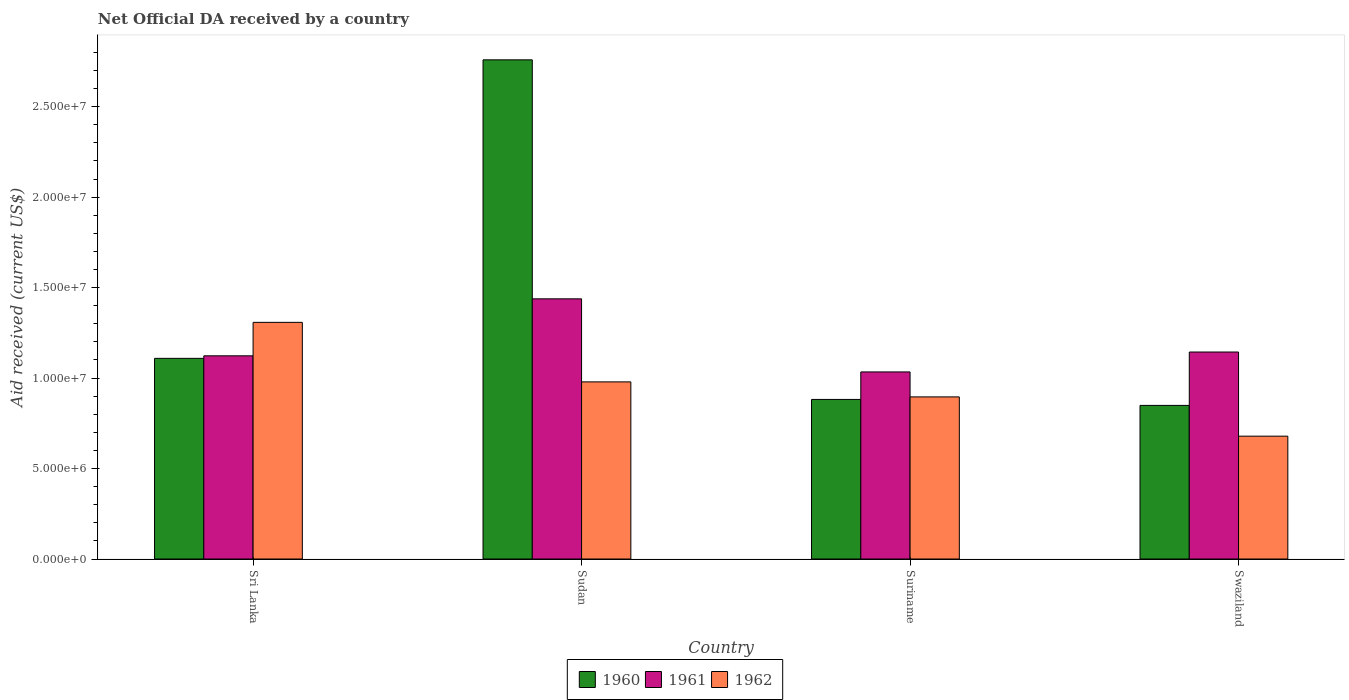Are the number of bars per tick equal to the number of legend labels?
Provide a succinct answer. Yes. What is the label of the 3rd group of bars from the left?
Offer a terse response. Suriname. What is the net official development assistance aid received in 1961 in Sudan?
Provide a short and direct response. 1.44e+07. Across all countries, what is the maximum net official development assistance aid received in 1961?
Provide a short and direct response. 1.44e+07. Across all countries, what is the minimum net official development assistance aid received in 1961?
Offer a terse response. 1.03e+07. In which country was the net official development assistance aid received in 1962 maximum?
Make the answer very short. Sri Lanka. In which country was the net official development assistance aid received in 1960 minimum?
Make the answer very short. Swaziland. What is the total net official development assistance aid received in 1960 in the graph?
Provide a short and direct response. 5.60e+07. What is the difference between the net official development assistance aid received in 1961 in Sudan and that in Swaziland?
Ensure brevity in your answer.  2.94e+06. What is the difference between the net official development assistance aid received in 1961 in Sri Lanka and the net official development assistance aid received in 1962 in Sudan?
Keep it short and to the point. 1.44e+06. What is the average net official development assistance aid received in 1962 per country?
Make the answer very short. 9.66e+06. What is the difference between the net official development assistance aid received of/in 1960 and net official development assistance aid received of/in 1962 in Swaziland?
Your response must be concise. 1.70e+06. What is the ratio of the net official development assistance aid received in 1961 in Sri Lanka to that in Suriname?
Keep it short and to the point. 1.09. What is the difference between the highest and the second highest net official development assistance aid received in 1961?
Your answer should be very brief. 3.15e+06. What is the difference between the highest and the lowest net official development assistance aid received in 1960?
Your response must be concise. 1.91e+07. In how many countries, is the net official development assistance aid received in 1960 greater than the average net official development assistance aid received in 1960 taken over all countries?
Keep it short and to the point. 1. What does the 1st bar from the right in Swaziland represents?
Your answer should be very brief. 1962. Is it the case that in every country, the sum of the net official development assistance aid received in 1962 and net official development assistance aid received in 1960 is greater than the net official development assistance aid received in 1961?
Offer a terse response. Yes. Are all the bars in the graph horizontal?
Give a very brief answer. No. What is the difference between two consecutive major ticks on the Y-axis?
Ensure brevity in your answer.  5.00e+06. Are the values on the major ticks of Y-axis written in scientific E-notation?
Your answer should be compact. Yes. Does the graph contain any zero values?
Offer a terse response. No. How many legend labels are there?
Give a very brief answer. 3. How are the legend labels stacked?
Your answer should be compact. Horizontal. What is the title of the graph?
Your answer should be very brief. Net Official DA received by a country. What is the label or title of the Y-axis?
Offer a terse response. Aid received (current US$). What is the Aid received (current US$) of 1960 in Sri Lanka?
Provide a succinct answer. 1.11e+07. What is the Aid received (current US$) in 1961 in Sri Lanka?
Provide a short and direct response. 1.12e+07. What is the Aid received (current US$) in 1962 in Sri Lanka?
Offer a terse response. 1.31e+07. What is the Aid received (current US$) of 1960 in Sudan?
Give a very brief answer. 2.76e+07. What is the Aid received (current US$) in 1961 in Sudan?
Your answer should be very brief. 1.44e+07. What is the Aid received (current US$) in 1962 in Sudan?
Your answer should be very brief. 9.79e+06. What is the Aid received (current US$) in 1960 in Suriname?
Keep it short and to the point. 8.82e+06. What is the Aid received (current US$) of 1961 in Suriname?
Your response must be concise. 1.03e+07. What is the Aid received (current US$) in 1962 in Suriname?
Your answer should be compact. 8.96e+06. What is the Aid received (current US$) in 1960 in Swaziland?
Ensure brevity in your answer.  8.49e+06. What is the Aid received (current US$) of 1961 in Swaziland?
Offer a very short reply. 1.14e+07. What is the Aid received (current US$) in 1962 in Swaziland?
Give a very brief answer. 6.79e+06. Across all countries, what is the maximum Aid received (current US$) in 1960?
Your response must be concise. 2.76e+07. Across all countries, what is the maximum Aid received (current US$) of 1961?
Your answer should be very brief. 1.44e+07. Across all countries, what is the maximum Aid received (current US$) in 1962?
Provide a short and direct response. 1.31e+07. Across all countries, what is the minimum Aid received (current US$) in 1960?
Provide a short and direct response. 8.49e+06. Across all countries, what is the minimum Aid received (current US$) in 1961?
Provide a succinct answer. 1.03e+07. Across all countries, what is the minimum Aid received (current US$) in 1962?
Provide a succinct answer. 6.79e+06. What is the total Aid received (current US$) in 1960 in the graph?
Provide a succinct answer. 5.60e+07. What is the total Aid received (current US$) of 1961 in the graph?
Offer a very short reply. 4.74e+07. What is the total Aid received (current US$) in 1962 in the graph?
Your answer should be very brief. 3.86e+07. What is the difference between the Aid received (current US$) in 1960 in Sri Lanka and that in Sudan?
Offer a very short reply. -1.65e+07. What is the difference between the Aid received (current US$) of 1961 in Sri Lanka and that in Sudan?
Keep it short and to the point. -3.15e+06. What is the difference between the Aid received (current US$) in 1962 in Sri Lanka and that in Sudan?
Give a very brief answer. 3.29e+06. What is the difference between the Aid received (current US$) in 1960 in Sri Lanka and that in Suriname?
Give a very brief answer. 2.27e+06. What is the difference between the Aid received (current US$) of 1961 in Sri Lanka and that in Suriname?
Offer a very short reply. 8.90e+05. What is the difference between the Aid received (current US$) in 1962 in Sri Lanka and that in Suriname?
Offer a terse response. 4.12e+06. What is the difference between the Aid received (current US$) of 1960 in Sri Lanka and that in Swaziland?
Ensure brevity in your answer.  2.60e+06. What is the difference between the Aid received (current US$) in 1962 in Sri Lanka and that in Swaziland?
Give a very brief answer. 6.29e+06. What is the difference between the Aid received (current US$) of 1960 in Sudan and that in Suriname?
Offer a terse response. 1.88e+07. What is the difference between the Aid received (current US$) in 1961 in Sudan and that in Suriname?
Provide a succinct answer. 4.04e+06. What is the difference between the Aid received (current US$) in 1962 in Sudan and that in Suriname?
Give a very brief answer. 8.30e+05. What is the difference between the Aid received (current US$) of 1960 in Sudan and that in Swaziland?
Give a very brief answer. 1.91e+07. What is the difference between the Aid received (current US$) of 1961 in Sudan and that in Swaziland?
Your answer should be very brief. 2.94e+06. What is the difference between the Aid received (current US$) of 1962 in Sudan and that in Swaziland?
Give a very brief answer. 3.00e+06. What is the difference between the Aid received (current US$) of 1960 in Suriname and that in Swaziland?
Keep it short and to the point. 3.30e+05. What is the difference between the Aid received (current US$) of 1961 in Suriname and that in Swaziland?
Make the answer very short. -1.10e+06. What is the difference between the Aid received (current US$) of 1962 in Suriname and that in Swaziland?
Your answer should be very brief. 2.17e+06. What is the difference between the Aid received (current US$) of 1960 in Sri Lanka and the Aid received (current US$) of 1961 in Sudan?
Provide a succinct answer. -3.29e+06. What is the difference between the Aid received (current US$) of 1960 in Sri Lanka and the Aid received (current US$) of 1962 in Sudan?
Ensure brevity in your answer.  1.30e+06. What is the difference between the Aid received (current US$) in 1961 in Sri Lanka and the Aid received (current US$) in 1962 in Sudan?
Your answer should be very brief. 1.44e+06. What is the difference between the Aid received (current US$) in 1960 in Sri Lanka and the Aid received (current US$) in 1961 in Suriname?
Make the answer very short. 7.50e+05. What is the difference between the Aid received (current US$) of 1960 in Sri Lanka and the Aid received (current US$) of 1962 in Suriname?
Your response must be concise. 2.13e+06. What is the difference between the Aid received (current US$) in 1961 in Sri Lanka and the Aid received (current US$) in 1962 in Suriname?
Provide a short and direct response. 2.27e+06. What is the difference between the Aid received (current US$) in 1960 in Sri Lanka and the Aid received (current US$) in 1961 in Swaziland?
Offer a very short reply. -3.50e+05. What is the difference between the Aid received (current US$) of 1960 in Sri Lanka and the Aid received (current US$) of 1962 in Swaziland?
Provide a short and direct response. 4.30e+06. What is the difference between the Aid received (current US$) in 1961 in Sri Lanka and the Aid received (current US$) in 1962 in Swaziland?
Your answer should be compact. 4.44e+06. What is the difference between the Aid received (current US$) of 1960 in Sudan and the Aid received (current US$) of 1961 in Suriname?
Ensure brevity in your answer.  1.72e+07. What is the difference between the Aid received (current US$) in 1960 in Sudan and the Aid received (current US$) in 1962 in Suriname?
Your answer should be compact. 1.86e+07. What is the difference between the Aid received (current US$) in 1961 in Sudan and the Aid received (current US$) in 1962 in Suriname?
Offer a very short reply. 5.42e+06. What is the difference between the Aid received (current US$) in 1960 in Sudan and the Aid received (current US$) in 1961 in Swaziland?
Provide a succinct answer. 1.62e+07. What is the difference between the Aid received (current US$) of 1960 in Sudan and the Aid received (current US$) of 1962 in Swaziland?
Offer a terse response. 2.08e+07. What is the difference between the Aid received (current US$) of 1961 in Sudan and the Aid received (current US$) of 1962 in Swaziland?
Provide a short and direct response. 7.59e+06. What is the difference between the Aid received (current US$) of 1960 in Suriname and the Aid received (current US$) of 1961 in Swaziland?
Offer a terse response. -2.62e+06. What is the difference between the Aid received (current US$) of 1960 in Suriname and the Aid received (current US$) of 1962 in Swaziland?
Make the answer very short. 2.03e+06. What is the difference between the Aid received (current US$) in 1961 in Suriname and the Aid received (current US$) in 1962 in Swaziland?
Provide a succinct answer. 3.55e+06. What is the average Aid received (current US$) in 1960 per country?
Offer a very short reply. 1.40e+07. What is the average Aid received (current US$) in 1961 per country?
Provide a succinct answer. 1.18e+07. What is the average Aid received (current US$) in 1962 per country?
Keep it short and to the point. 9.66e+06. What is the difference between the Aid received (current US$) of 1960 and Aid received (current US$) of 1962 in Sri Lanka?
Your answer should be compact. -1.99e+06. What is the difference between the Aid received (current US$) in 1961 and Aid received (current US$) in 1962 in Sri Lanka?
Ensure brevity in your answer.  -1.85e+06. What is the difference between the Aid received (current US$) of 1960 and Aid received (current US$) of 1961 in Sudan?
Your answer should be very brief. 1.32e+07. What is the difference between the Aid received (current US$) in 1960 and Aid received (current US$) in 1962 in Sudan?
Provide a succinct answer. 1.78e+07. What is the difference between the Aid received (current US$) in 1961 and Aid received (current US$) in 1962 in Sudan?
Give a very brief answer. 4.59e+06. What is the difference between the Aid received (current US$) in 1960 and Aid received (current US$) in 1961 in Suriname?
Your answer should be very brief. -1.52e+06. What is the difference between the Aid received (current US$) in 1961 and Aid received (current US$) in 1962 in Suriname?
Your answer should be compact. 1.38e+06. What is the difference between the Aid received (current US$) of 1960 and Aid received (current US$) of 1961 in Swaziland?
Give a very brief answer. -2.95e+06. What is the difference between the Aid received (current US$) in 1960 and Aid received (current US$) in 1962 in Swaziland?
Give a very brief answer. 1.70e+06. What is the difference between the Aid received (current US$) of 1961 and Aid received (current US$) of 1962 in Swaziland?
Provide a succinct answer. 4.65e+06. What is the ratio of the Aid received (current US$) in 1960 in Sri Lanka to that in Sudan?
Your answer should be compact. 0.4. What is the ratio of the Aid received (current US$) of 1961 in Sri Lanka to that in Sudan?
Keep it short and to the point. 0.78. What is the ratio of the Aid received (current US$) in 1962 in Sri Lanka to that in Sudan?
Give a very brief answer. 1.34. What is the ratio of the Aid received (current US$) in 1960 in Sri Lanka to that in Suriname?
Provide a short and direct response. 1.26. What is the ratio of the Aid received (current US$) of 1961 in Sri Lanka to that in Suriname?
Ensure brevity in your answer.  1.09. What is the ratio of the Aid received (current US$) of 1962 in Sri Lanka to that in Suriname?
Your answer should be compact. 1.46. What is the ratio of the Aid received (current US$) in 1960 in Sri Lanka to that in Swaziland?
Give a very brief answer. 1.31. What is the ratio of the Aid received (current US$) of 1961 in Sri Lanka to that in Swaziland?
Give a very brief answer. 0.98. What is the ratio of the Aid received (current US$) in 1962 in Sri Lanka to that in Swaziland?
Provide a short and direct response. 1.93. What is the ratio of the Aid received (current US$) of 1960 in Sudan to that in Suriname?
Your answer should be very brief. 3.13. What is the ratio of the Aid received (current US$) of 1961 in Sudan to that in Suriname?
Your answer should be compact. 1.39. What is the ratio of the Aid received (current US$) in 1962 in Sudan to that in Suriname?
Provide a succinct answer. 1.09. What is the ratio of the Aid received (current US$) in 1960 in Sudan to that in Swaziland?
Your response must be concise. 3.25. What is the ratio of the Aid received (current US$) of 1961 in Sudan to that in Swaziland?
Provide a short and direct response. 1.26. What is the ratio of the Aid received (current US$) of 1962 in Sudan to that in Swaziland?
Provide a short and direct response. 1.44. What is the ratio of the Aid received (current US$) in 1960 in Suriname to that in Swaziland?
Your answer should be very brief. 1.04. What is the ratio of the Aid received (current US$) of 1961 in Suriname to that in Swaziland?
Your response must be concise. 0.9. What is the ratio of the Aid received (current US$) of 1962 in Suriname to that in Swaziland?
Ensure brevity in your answer.  1.32. What is the difference between the highest and the second highest Aid received (current US$) of 1960?
Your answer should be very brief. 1.65e+07. What is the difference between the highest and the second highest Aid received (current US$) of 1961?
Your response must be concise. 2.94e+06. What is the difference between the highest and the second highest Aid received (current US$) in 1962?
Offer a very short reply. 3.29e+06. What is the difference between the highest and the lowest Aid received (current US$) in 1960?
Your answer should be very brief. 1.91e+07. What is the difference between the highest and the lowest Aid received (current US$) in 1961?
Your answer should be very brief. 4.04e+06. What is the difference between the highest and the lowest Aid received (current US$) of 1962?
Offer a very short reply. 6.29e+06. 